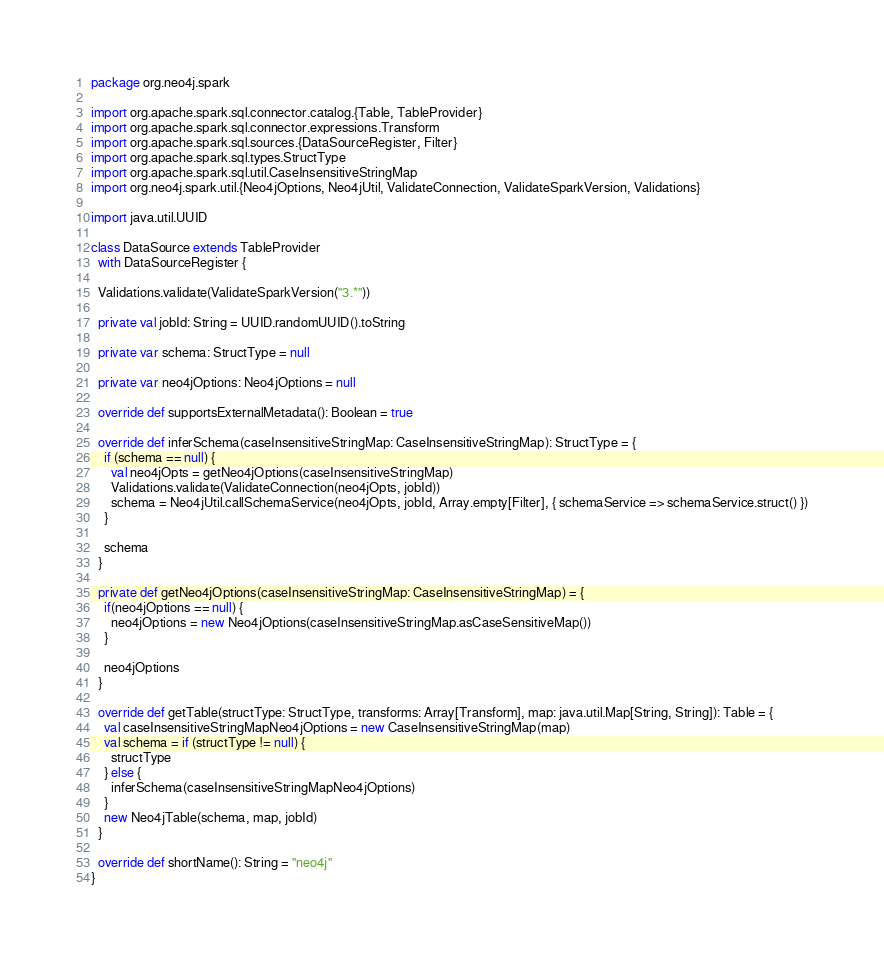<code> <loc_0><loc_0><loc_500><loc_500><_Scala_>package org.neo4j.spark

import org.apache.spark.sql.connector.catalog.{Table, TableProvider}
import org.apache.spark.sql.connector.expressions.Transform
import org.apache.spark.sql.sources.{DataSourceRegister, Filter}
import org.apache.spark.sql.types.StructType
import org.apache.spark.sql.util.CaseInsensitiveStringMap
import org.neo4j.spark.util.{Neo4jOptions, Neo4jUtil, ValidateConnection, ValidateSparkVersion, Validations}

import java.util.UUID

class DataSource extends TableProvider
  with DataSourceRegister {

  Validations.validate(ValidateSparkVersion("3.*"))

  private val jobId: String = UUID.randomUUID().toString

  private var schema: StructType = null

  private var neo4jOptions: Neo4jOptions = null

  override def supportsExternalMetadata(): Boolean = true

  override def inferSchema(caseInsensitiveStringMap: CaseInsensitiveStringMap): StructType = {
    if (schema == null) {
      val neo4jOpts = getNeo4jOptions(caseInsensitiveStringMap)
      Validations.validate(ValidateConnection(neo4jOpts, jobId))
      schema = Neo4jUtil.callSchemaService(neo4jOpts, jobId, Array.empty[Filter], { schemaService => schemaService.struct() })
    }

    schema
  }

  private def getNeo4jOptions(caseInsensitiveStringMap: CaseInsensitiveStringMap) = {
    if(neo4jOptions == null) {
      neo4jOptions = new Neo4jOptions(caseInsensitiveStringMap.asCaseSensitiveMap())
    }

    neo4jOptions
  }

  override def getTable(structType: StructType, transforms: Array[Transform], map: java.util.Map[String, String]): Table = {
    val caseInsensitiveStringMapNeo4jOptions = new CaseInsensitiveStringMap(map)
    val schema = if (structType != null) {
      structType
    } else {
      inferSchema(caseInsensitiveStringMapNeo4jOptions)
    }
    new Neo4jTable(schema, map, jobId)
  }

  override def shortName(): String = "neo4j"
}
</code> 